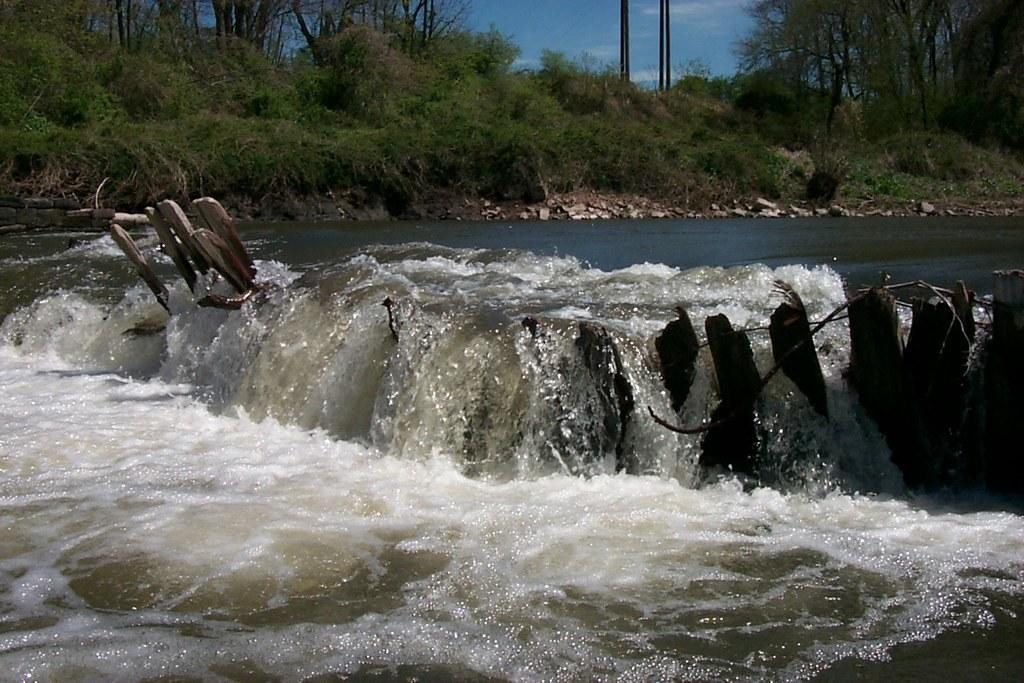What is the primary element visible in the image? There is water in the image. What can be seen in the background of the image? There are groups of trees in the background of the image. What is visible in the sky in the image? There are clouds in the sky. What type of lettuce is being used as a kite in the image? There is no lettuce or kite present in the image. 